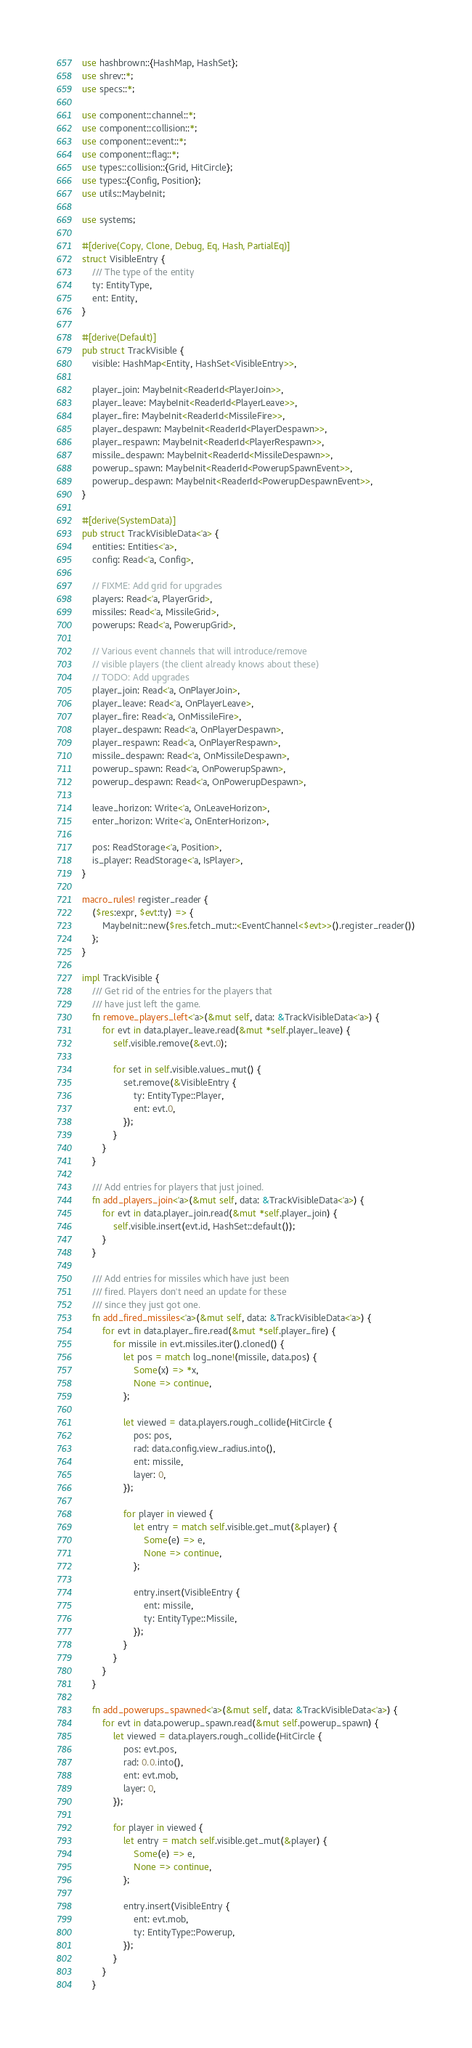Convert code to text. <code><loc_0><loc_0><loc_500><loc_500><_Rust_>use hashbrown::{HashMap, HashSet};
use shrev::*;
use specs::*;

use component::channel::*;
use component::collision::*;
use component::event::*;
use component::flag::*;
use types::collision::{Grid, HitCircle};
use types::{Config, Position};
use utils::MaybeInit;

use systems;

#[derive(Copy, Clone, Debug, Eq, Hash, PartialEq)]
struct VisibleEntry {
	/// The type of the entity
	ty: EntityType,
	ent: Entity,
}

#[derive(Default)]
pub struct TrackVisible {
	visible: HashMap<Entity, HashSet<VisibleEntry>>,

	player_join: MaybeInit<ReaderId<PlayerJoin>>,
	player_leave: MaybeInit<ReaderId<PlayerLeave>>,
	player_fire: MaybeInit<ReaderId<MissileFire>>,
	player_despawn: MaybeInit<ReaderId<PlayerDespawn>>,
	player_respawn: MaybeInit<ReaderId<PlayerRespawn>>,
	missile_despawn: MaybeInit<ReaderId<MissileDespawn>>,
	powerup_spawn: MaybeInit<ReaderId<PowerupSpawnEvent>>,
	powerup_despawn: MaybeInit<ReaderId<PowerupDespawnEvent>>,
}

#[derive(SystemData)]
pub struct TrackVisibleData<'a> {
	entities: Entities<'a>,
	config: Read<'a, Config>,

	// FIXME: Add grid for upgrades
	players: Read<'a, PlayerGrid>,
	missiles: Read<'a, MissileGrid>,
	powerups: Read<'a, PowerupGrid>,

	// Various event channels that will introduce/remove
	// visible players (the client already knows about these)
	// TODO: Add upgrades
	player_join: Read<'a, OnPlayerJoin>,
	player_leave: Read<'a, OnPlayerLeave>,
	player_fire: Read<'a, OnMissileFire>,
	player_despawn: Read<'a, OnPlayerDespawn>,
	player_respawn: Read<'a, OnPlayerRespawn>,
	missile_despawn: Read<'a, OnMissileDespawn>,
	powerup_spawn: Read<'a, OnPowerupSpawn>,
	powerup_despawn: Read<'a, OnPowerupDespawn>,

	leave_horizon: Write<'a, OnLeaveHorizon>,
	enter_horizon: Write<'a, OnEnterHorizon>,

	pos: ReadStorage<'a, Position>,
	is_player: ReadStorage<'a, IsPlayer>,
}

macro_rules! register_reader {
	($res:expr, $evt:ty) => {
		MaybeInit::new($res.fetch_mut::<EventChannel<$evt>>().register_reader())
	};
}

impl TrackVisible {
	/// Get rid of the entries for the players that
	/// have just left the game.
	fn remove_players_left<'a>(&mut self, data: &TrackVisibleData<'a>) {
		for evt in data.player_leave.read(&mut *self.player_leave) {
			self.visible.remove(&evt.0);

			for set in self.visible.values_mut() {
				set.remove(&VisibleEntry {
					ty: EntityType::Player,
					ent: evt.0,
				});
			}
		}
	}

	/// Add entries for players that just joined.
	fn add_players_join<'a>(&mut self, data: &TrackVisibleData<'a>) {
		for evt in data.player_join.read(&mut *self.player_join) {
			self.visible.insert(evt.id, HashSet::default());
		}
	}

	/// Add entries for missiles which have just been
	/// fired. Players don't need an update for these
	/// since they just got one.
	fn add_fired_missiles<'a>(&mut self, data: &TrackVisibleData<'a>) {
		for evt in data.player_fire.read(&mut *self.player_fire) {
			for missile in evt.missiles.iter().cloned() {
				let pos = match log_none!(missile, data.pos) {
					Some(x) => *x,
					None => continue,
				};

				let viewed = data.players.rough_collide(HitCircle {
					pos: pos,
					rad: data.config.view_radius.into(),
					ent: missile,
					layer: 0,
				});

				for player in viewed {
					let entry = match self.visible.get_mut(&player) {
						Some(e) => e,
						None => continue,
					};

					entry.insert(VisibleEntry {
						ent: missile,
						ty: EntityType::Missile,
					});
				}
			}
		}
	}

	fn add_powerups_spawned<'a>(&mut self, data: &TrackVisibleData<'a>) {
		for evt in data.powerup_spawn.read(&mut self.powerup_spawn) {
			let viewed = data.players.rough_collide(HitCircle {
				pos: evt.pos,
				rad: 0.0.into(),
				ent: evt.mob,
				layer: 0,
			});

			for player in viewed {
				let entry = match self.visible.get_mut(&player) {
					Some(e) => e,
					None => continue,
				};

				entry.insert(VisibleEntry {
					ent: evt.mob,
					ty: EntityType::Powerup,
				});
			}
		}
	}
</code> 